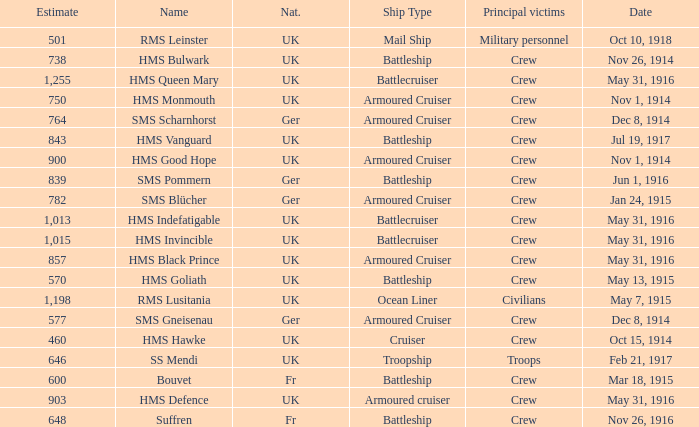What is the nationality of the ship when the principle victims are civilians? UK. 